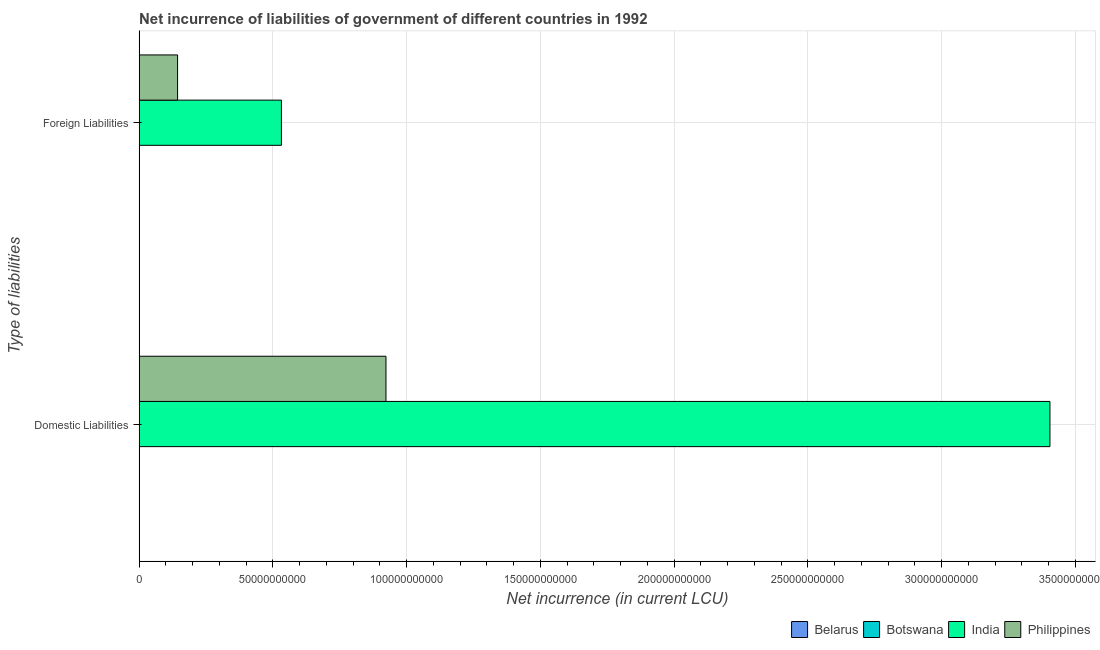How many different coloured bars are there?
Your answer should be compact. 4. Are the number of bars on each tick of the Y-axis equal?
Give a very brief answer. No. What is the label of the 1st group of bars from the top?
Your answer should be very brief. Foreign Liabilities. What is the net incurrence of domestic liabilities in India?
Your answer should be compact. 3.41e+11. Across all countries, what is the maximum net incurrence of foreign liabilities?
Offer a terse response. 5.32e+1. Across all countries, what is the minimum net incurrence of foreign liabilities?
Your answer should be very brief. 2.50e+06. What is the total net incurrence of domestic liabilities in the graph?
Your answer should be compact. 4.33e+11. What is the difference between the net incurrence of foreign liabilities in Belarus and that in Botswana?
Keep it short and to the point. -7.70e+07. What is the difference between the net incurrence of foreign liabilities in India and the net incurrence of domestic liabilities in Philippines?
Ensure brevity in your answer.  -3.91e+1. What is the average net incurrence of foreign liabilities per country?
Give a very brief answer. 1.69e+1. What is the difference between the net incurrence of foreign liabilities and net incurrence of domestic liabilities in India?
Make the answer very short. -2.87e+11. What is the ratio of the net incurrence of foreign liabilities in Philippines to that in Belarus?
Offer a terse response. 5756. In how many countries, is the net incurrence of foreign liabilities greater than the average net incurrence of foreign liabilities taken over all countries?
Give a very brief answer. 1. Are all the bars in the graph horizontal?
Offer a very short reply. Yes. What is the difference between two consecutive major ticks on the X-axis?
Offer a very short reply. 5.00e+1. Are the values on the major ticks of X-axis written in scientific E-notation?
Make the answer very short. No. Does the graph contain any zero values?
Provide a short and direct response. Yes. Where does the legend appear in the graph?
Your answer should be compact. Bottom right. How many legend labels are there?
Provide a succinct answer. 4. What is the title of the graph?
Your response must be concise. Net incurrence of liabilities of government of different countries in 1992. Does "Least developed countries" appear as one of the legend labels in the graph?
Ensure brevity in your answer.  No. What is the label or title of the X-axis?
Your answer should be compact. Net incurrence (in current LCU). What is the label or title of the Y-axis?
Provide a succinct answer. Type of liabilities. What is the Net incurrence (in current LCU) in Belarus in Domestic Liabilities?
Make the answer very short. 2.20e+06. What is the Net incurrence (in current LCU) in India in Domestic Liabilities?
Keep it short and to the point. 3.41e+11. What is the Net incurrence (in current LCU) in Philippines in Domestic Liabilities?
Your response must be concise. 9.23e+1. What is the Net incurrence (in current LCU) in Belarus in Foreign Liabilities?
Your answer should be compact. 2.50e+06. What is the Net incurrence (in current LCU) in Botswana in Foreign Liabilities?
Your answer should be compact. 7.95e+07. What is the Net incurrence (in current LCU) in India in Foreign Liabilities?
Provide a succinct answer. 5.32e+1. What is the Net incurrence (in current LCU) in Philippines in Foreign Liabilities?
Your answer should be compact. 1.44e+1. Across all Type of liabilities, what is the maximum Net incurrence (in current LCU) of Belarus?
Provide a succinct answer. 2.50e+06. Across all Type of liabilities, what is the maximum Net incurrence (in current LCU) of Botswana?
Offer a very short reply. 7.95e+07. Across all Type of liabilities, what is the maximum Net incurrence (in current LCU) in India?
Offer a very short reply. 3.41e+11. Across all Type of liabilities, what is the maximum Net incurrence (in current LCU) in Philippines?
Offer a very short reply. 9.23e+1. Across all Type of liabilities, what is the minimum Net incurrence (in current LCU) of Belarus?
Your answer should be very brief. 2.20e+06. Across all Type of liabilities, what is the minimum Net incurrence (in current LCU) in India?
Make the answer very short. 5.32e+1. Across all Type of liabilities, what is the minimum Net incurrence (in current LCU) of Philippines?
Make the answer very short. 1.44e+1. What is the total Net incurrence (in current LCU) of Belarus in the graph?
Ensure brevity in your answer.  4.70e+06. What is the total Net incurrence (in current LCU) in Botswana in the graph?
Give a very brief answer. 7.95e+07. What is the total Net incurrence (in current LCU) in India in the graph?
Keep it short and to the point. 3.94e+11. What is the total Net incurrence (in current LCU) of Philippines in the graph?
Offer a very short reply. 1.07e+11. What is the difference between the Net incurrence (in current LCU) of Belarus in Domestic Liabilities and that in Foreign Liabilities?
Your answer should be compact. -3.00e+05. What is the difference between the Net incurrence (in current LCU) in India in Domestic Liabilities and that in Foreign Liabilities?
Your response must be concise. 2.87e+11. What is the difference between the Net incurrence (in current LCU) in Philippines in Domestic Liabilities and that in Foreign Liabilities?
Ensure brevity in your answer.  7.79e+1. What is the difference between the Net incurrence (in current LCU) in Belarus in Domestic Liabilities and the Net incurrence (in current LCU) in Botswana in Foreign Liabilities?
Your answer should be very brief. -7.73e+07. What is the difference between the Net incurrence (in current LCU) of Belarus in Domestic Liabilities and the Net incurrence (in current LCU) of India in Foreign Liabilities?
Your answer should be compact. -5.32e+1. What is the difference between the Net incurrence (in current LCU) in Belarus in Domestic Liabilities and the Net incurrence (in current LCU) in Philippines in Foreign Liabilities?
Keep it short and to the point. -1.44e+1. What is the difference between the Net incurrence (in current LCU) in India in Domestic Liabilities and the Net incurrence (in current LCU) in Philippines in Foreign Liabilities?
Provide a succinct answer. 3.26e+11. What is the average Net incurrence (in current LCU) in Belarus per Type of liabilities?
Provide a short and direct response. 2.35e+06. What is the average Net incurrence (in current LCU) in Botswana per Type of liabilities?
Provide a succinct answer. 3.98e+07. What is the average Net incurrence (in current LCU) of India per Type of liabilities?
Give a very brief answer. 1.97e+11. What is the average Net incurrence (in current LCU) of Philippines per Type of liabilities?
Provide a succinct answer. 5.33e+1. What is the difference between the Net incurrence (in current LCU) in Belarus and Net incurrence (in current LCU) in India in Domestic Liabilities?
Your answer should be very brief. -3.41e+11. What is the difference between the Net incurrence (in current LCU) of Belarus and Net incurrence (in current LCU) of Philippines in Domestic Liabilities?
Offer a very short reply. -9.23e+1. What is the difference between the Net incurrence (in current LCU) in India and Net incurrence (in current LCU) in Philippines in Domestic Liabilities?
Your response must be concise. 2.48e+11. What is the difference between the Net incurrence (in current LCU) of Belarus and Net incurrence (in current LCU) of Botswana in Foreign Liabilities?
Make the answer very short. -7.70e+07. What is the difference between the Net incurrence (in current LCU) of Belarus and Net incurrence (in current LCU) of India in Foreign Liabilities?
Your response must be concise. -5.32e+1. What is the difference between the Net incurrence (in current LCU) in Belarus and Net incurrence (in current LCU) in Philippines in Foreign Liabilities?
Provide a short and direct response. -1.44e+1. What is the difference between the Net incurrence (in current LCU) of Botswana and Net incurrence (in current LCU) of India in Foreign Liabilities?
Make the answer very short. -5.31e+1. What is the difference between the Net incurrence (in current LCU) of Botswana and Net incurrence (in current LCU) of Philippines in Foreign Liabilities?
Offer a very short reply. -1.43e+1. What is the difference between the Net incurrence (in current LCU) in India and Net incurrence (in current LCU) in Philippines in Foreign Liabilities?
Your answer should be very brief. 3.88e+1. What is the ratio of the Net incurrence (in current LCU) in Belarus in Domestic Liabilities to that in Foreign Liabilities?
Provide a succinct answer. 0.88. What is the ratio of the Net incurrence (in current LCU) of India in Domestic Liabilities to that in Foreign Liabilities?
Provide a short and direct response. 6.4. What is the ratio of the Net incurrence (in current LCU) of Philippines in Domestic Liabilities to that in Foreign Liabilities?
Offer a very short reply. 6.41. What is the difference between the highest and the second highest Net incurrence (in current LCU) of Belarus?
Make the answer very short. 3.00e+05. What is the difference between the highest and the second highest Net incurrence (in current LCU) of India?
Make the answer very short. 2.87e+11. What is the difference between the highest and the second highest Net incurrence (in current LCU) in Philippines?
Provide a short and direct response. 7.79e+1. What is the difference between the highest and the lowest Net incurrence (in current LCU) of Belarus?
Your response must be concise. 3.00e+05. What is the difference between the highest and the lowest Net incurrence (in current LCU) in Botswana?
Your response must be concise. 7.95e+07. What is the difference between the highest and the lowest Net incurrence (in current LCU) in India?
Your answer should be very brief. 2.87e+11. What is the difference between the highest and the lowest Net incurrence (in current LCU) of Philippines?
Make the answer very short. 7.79e+1. 